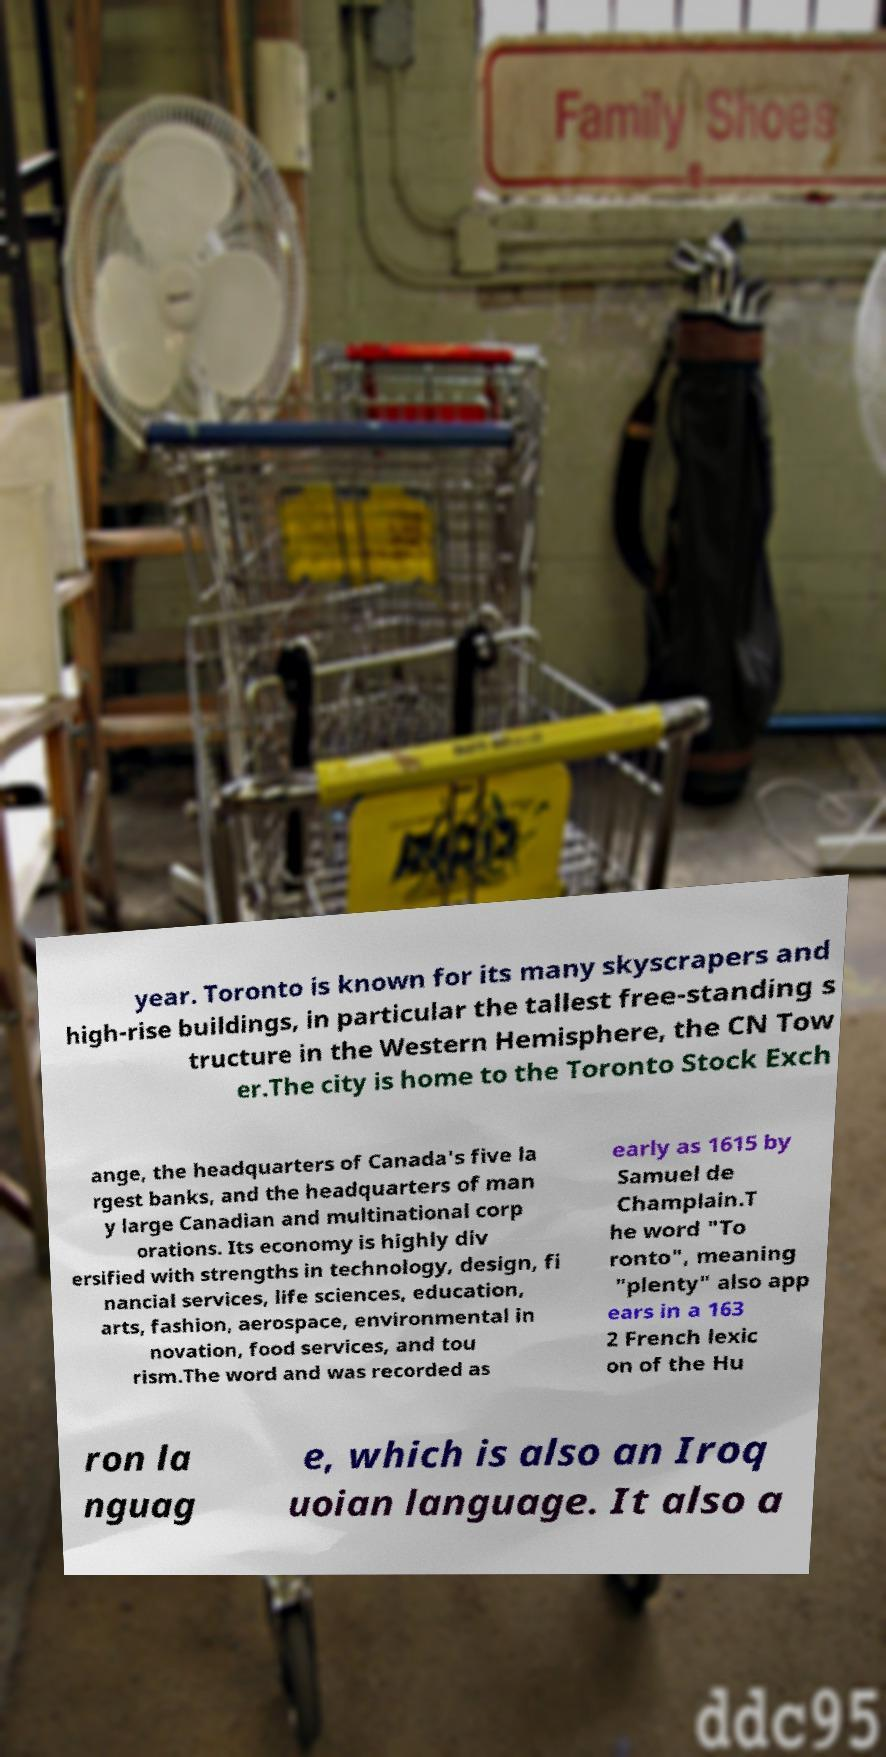Could you assist in decoding the text presented in this image and type it out clearly? year. Toronto is known for its many skyscrapers and high-rise buildings, in particular the tallest free-standing s tructure in the Western Hemisphere, the CN Tow er.The city is home to the Toronto Stock Exch ange, the headquarters of Canada's five la rgest banks, and the headquarters of man y large Canadian and multinational corp orations. Its economy is highly div ersified with strengths in technology, design, fi nancial services, life sciences, education, arts, fashion, aerospace, environmental in novation, food services, and tou rism.The word and was recorded as early as 1615 by Samuel de Champlain.T he word "To ronto", meaning "plenty" also app ears in a 163 2 French lexic on of the Hu ron la nguag e, which is also an Iroq uoian language. It also a 